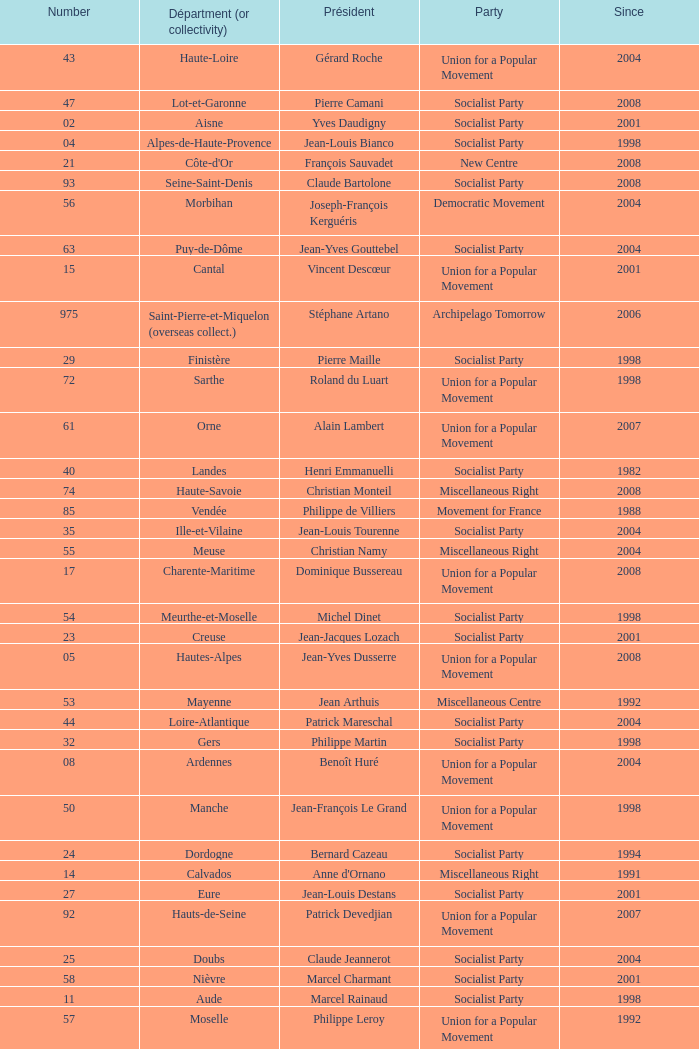Which department has Guy-Dominique Kennel as president since 2008? Bas-Rhin. 